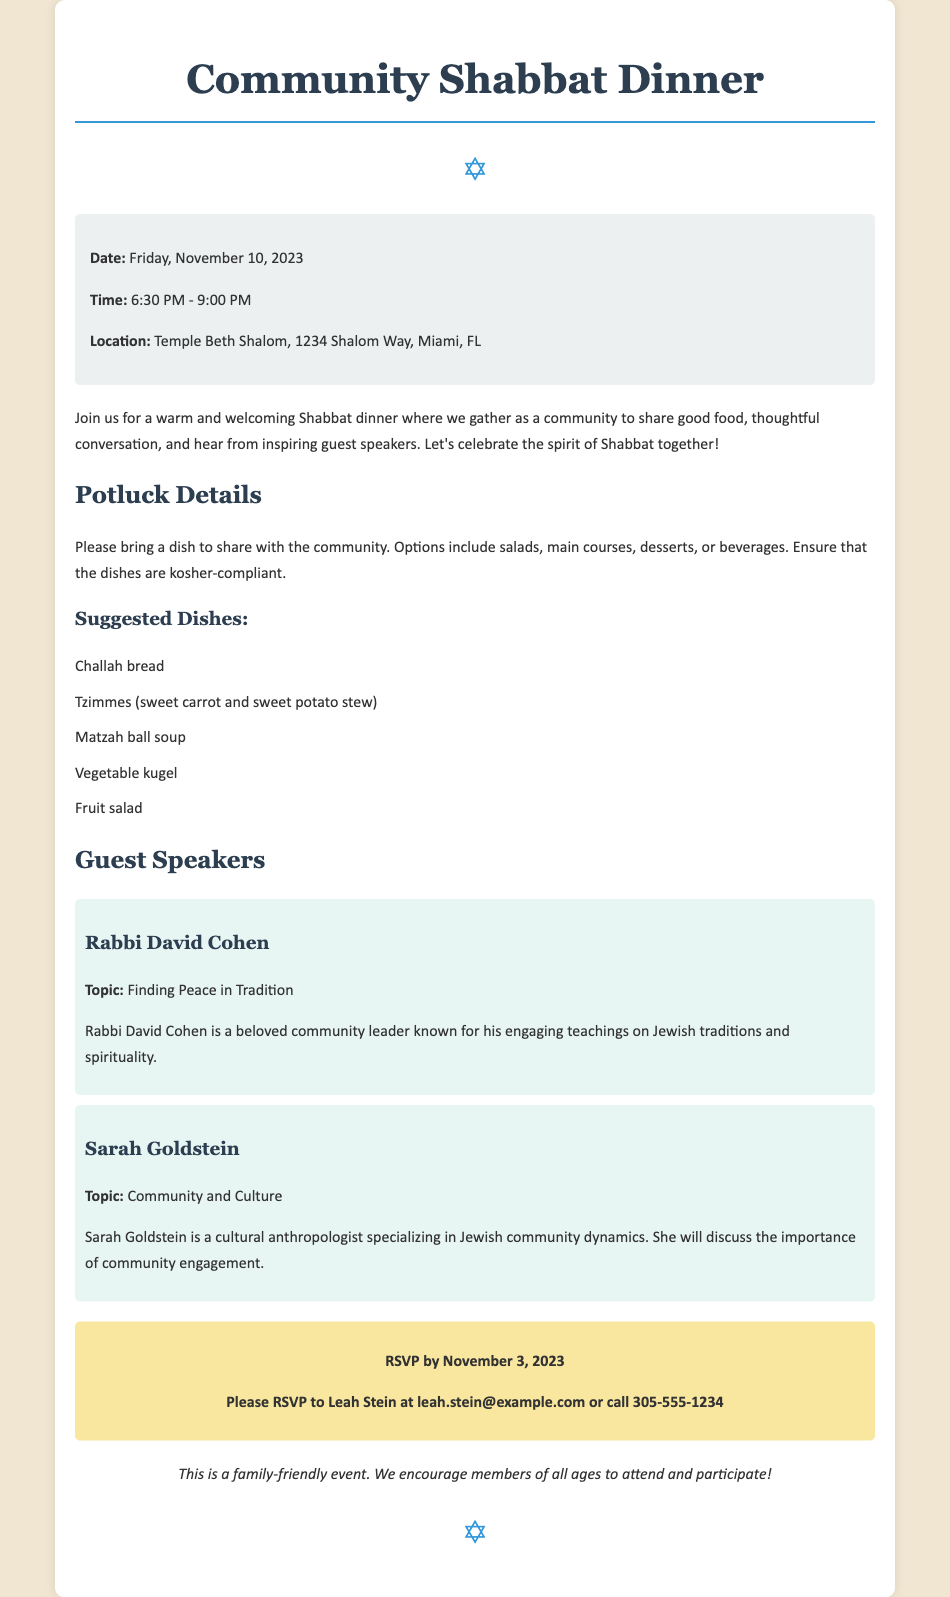What is the date of the Shabbat dinner? The document states that the Shabbat dinner is on Friday, November 10, 2023.
Answer: Friday, November 10, 2023 What time does the dinner start? The document specifies that the dinner starts at 6:30 PM.
Answer: 6:30 PM Where is the event being held? According to the document, the event will take place at Temple Beth Shalom, 1234 Shalom Way, Miami, FL.
Answer: Temple Beth Shalom, 1234 Shalom Way, Miami, FL Who is one of the guest speakers? The document lists Rabbi David Cohen as one of the speakers.
Answer: Rabbi David Cohen What is a suggested dish to bring for the potluck? The document provides several options, one of which is Challah bread.
Answer: Challah bread What is the RSVP deadline? The document mentions that RSVPs must be submitted by November 3, 2023.
Answer: November 3, 2023 How can participants RSVP? The document indicates that attendees can RSVP to Leah Stein at the provided email or phone number.
Answer: leah.stein@example.com or call 305-555-1234 What is a topic that Sarah Goldstein will speak about? The document states that Sarah Goldstein's topic is "Community and Culture."
Answer: Community and Culture Is this event family-friendly? The document states that this is a family-friendly event, encouraging members of all ages to attend.
Answer: Yes 